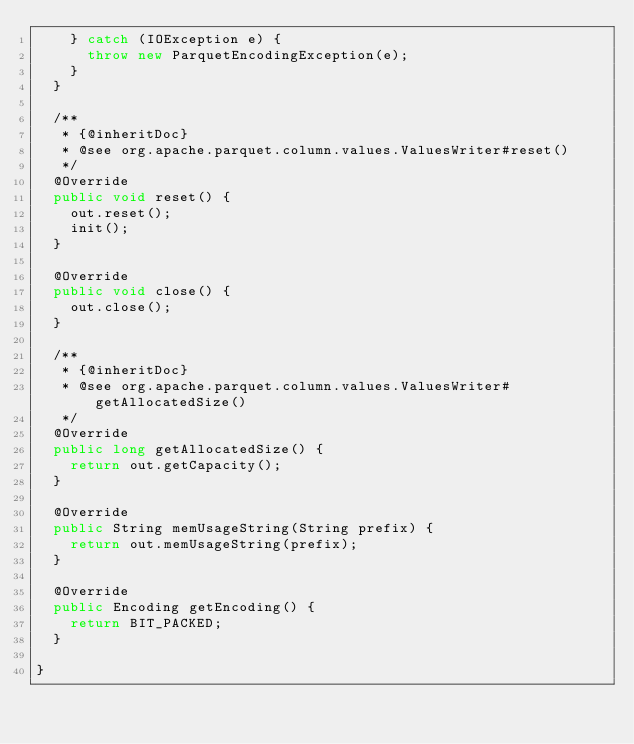<code> <loc_0><loc_0><loc_500><loc_500><_Java_>    } catch (IOException e) {
      throw new ParquetEncodingException(e);
    }
  }

  /**
   * {@inheritDoc}
   * @see org.apache.parquet.column.values.ValuesWriter#reset()
   */
  @Override
  public void reset() {
    out.reset();
    init();
  }

  @Override
  public void close() {
    out.close();
  }

  /**
   * {@inheritDoc}
   * @see org.apache.parquet.column.values.ValuesWriter#getAllocatedSize()
   */
  @Override
  public long getAllocatedSize() {
    return out.getCapacity();
  }

  @Override
  public String memUsageString(String prefix) {
    return out.memUsageString(prefix);
  }

  @Override
  public Encoding getEncoding() {
    return BIT_PACKED;
  }

}
</code> 